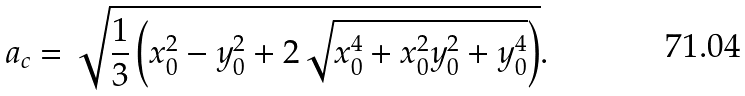Convert formula to latex. <formula><loc_0><loc_0><loc_500><loc_500>a _ { c } = \sqrt { \frac { 1 } { 3 } \left ( x _ { 0 } ^ { 2 } - y _ { 0 } ^ { 2 } + 2 \sqrt { x _ { 0 } ^ { 4 } + x _ { 0 } ^ { 2 } y _ { 0 } ^ { 2 } + y _ { 0 } ^ { 4 } } \right ) } .</formula> 